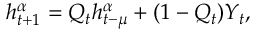<formula> <loc_0><loc_0><loc_500><loc_500>h _ { t + 1 } ^ { \alpha } = Q _ { t } h _ { t - \mu } ^ { \alpha } + ( 1 - Q _ { t } ) Y _ { t } ,</formula> 